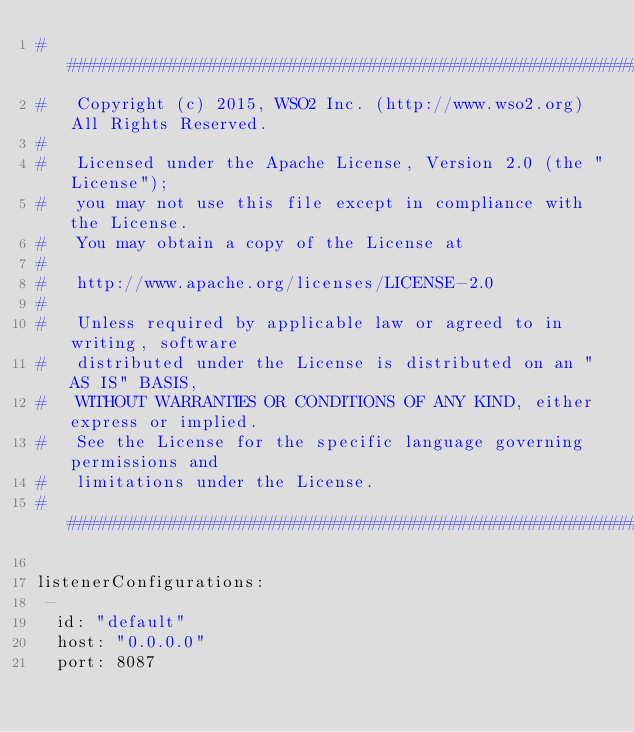Convert code to text. <code><loc_0><loc_0><loc_500><loc_500><_YAML_>################################################################################
#   Copyright (c) 2015, WSO2 Inc. (http://www.wso2.org) All Rights Reserved.
#
#   Licensed under the Apache License, Version 2.0 (the "License");
#   you may not use this file except in compliance with the License.
#   You may obtain a copy of the License at
#
#   http://www.apache.org/licenses/LICENSE-2.0
#
#   Unless required by applicable law or agreed to in writing, software
#   distributed under the License is distributed on an "AS IS" BASIS,
#   WITHOUT WARRANTIES OR CONDITIONS OF ANY KIND, either express or implied.
#   See the License for the specific language governing permissions and
#   limitations under the License.
################################################################################

listenerConfigurations:
 -
  id: "default"
  host: "0.0.0.0"
  port: 8087



</code> 